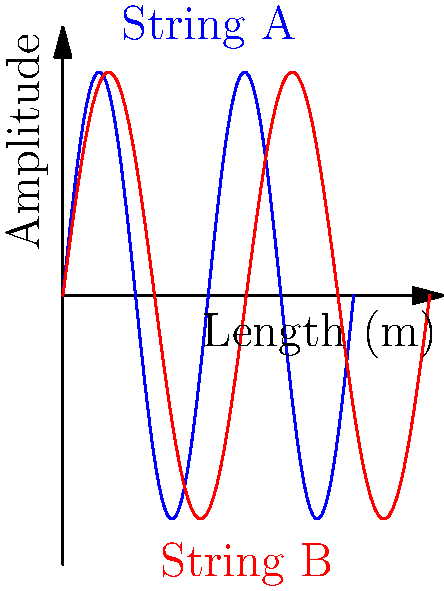At a blues jam session in Melbourne, you're tuning your guitar and notice two strings vibrating as shown in the diagram. String A (blue) has a wavelength of 0.65 meters, while String B (red) has a wavelength of 0.82 meters. If the speed of sound in the strings is 340 m/s, what is the difference in frequency between these two strings? Round your answer to the nearest Hz. Let's approach this step-by-step:

1) The formula for frequency is: $f = \frac{v}{\lambda}$, where $f$ is frequency, $v$ is velocity, and $\lambda$ is wavelength.

2) For String A:
   $f_A = \frac{v}{\lambda_A} = \frac{340 \text{ m/s}}{0.65 \text{ m}} = 523.08 \text{ Hz}$

3) For String B:
   $f_B = \frac{v}{\lambda_B} = \frac{340 \text{ m/s}}{0.82 \text{ m}} = 414.63 \text{ Hz}$

4) To find the difference in frequency:
   $\Delta f = f_A - f_B = 523.08 \text{ Hz} - 414.63 \text{ Hz} = 108.45 \text{ Hz}$

5) Rounding to the nearest Hz:
   $\Delta f \approx 108 \text{ Hz}$
Answer: 108 Hz 